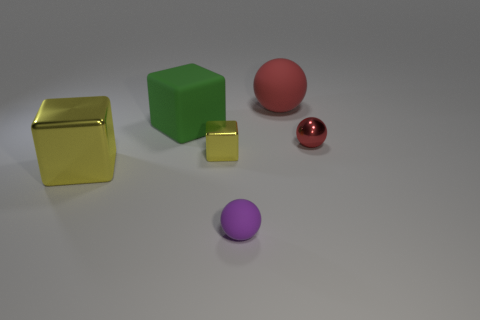Add 4 yellow shiny blocks. How many objects exist? 10 Add 2 small metallic things. How many small metallic things exist? 4 Subtract 0 purple cylinders. How many objects are left? 6 Subtract all large brown metallic things. Subtract all big green blocks. How many objects are left? 5 Add 4 tiny yellow shiny objects. How many tiny yellow shiny objects are left? 5 